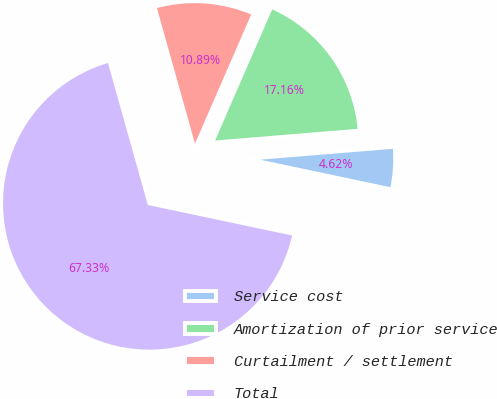Convert chart. <chart><loc_0><loc_0><loc_500><loc_500><pie_chart><fcel>Service cost<fcel>Amortization of prior service<fcel>Curtailment / settlement<fcel>Total<nl><fcel>4.62%<fcel>17.16%<fcel>10.89%<fcel>67.33%<nl></chart> 